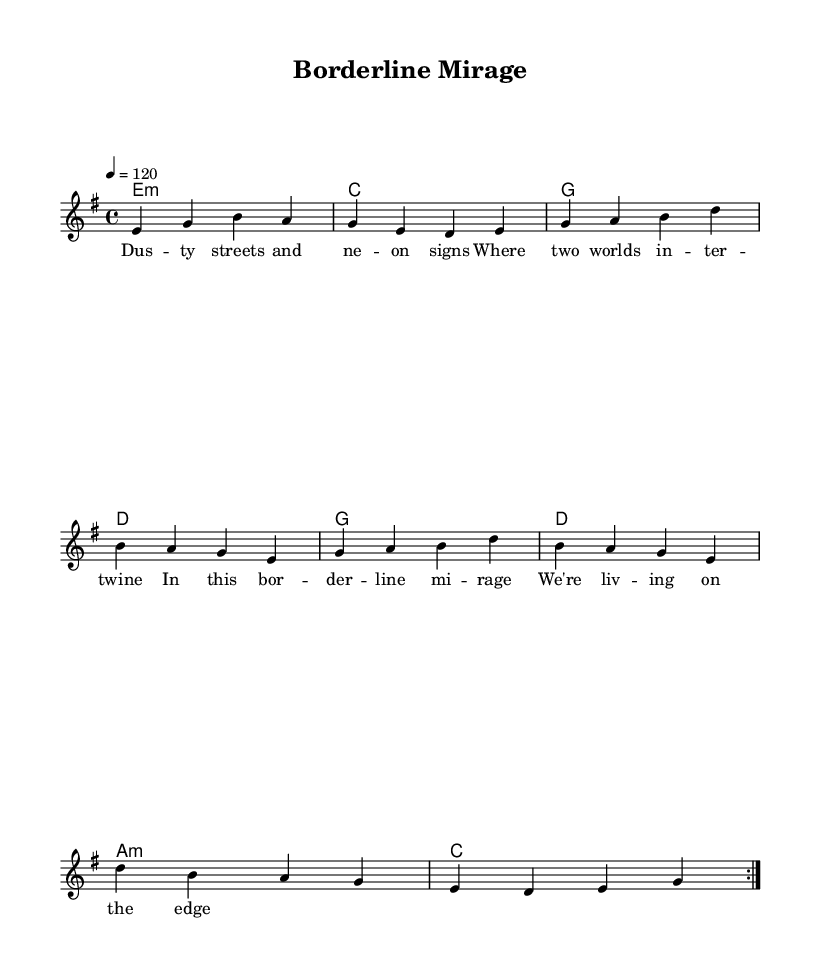What is the key signature of this music? The key signature is indicated at the beginning of the staff, showing that there is one sharp, which corresponds to E minor.
Answer: E minor What is the time signature of this music? The time signature is located next to the key signature at the beginning, which is four beats per measure, indicated as 4/4.
Answer: 4/4 What is the tempo marking of this piece? The tempo is indicated with a number and note value at the beginning of the score, showing 120 beats per minute, which is a moderate pace.
Answer: 120 How many measures are repeated in the melody? The score shows a 'repeat volta 2' directive, which indicates that the melody section is intended to be played two times.
Answer: 2 What chord is used on the first beat of the first measure? The first chord appears at the beginning of the harmonies section and is noted as an E minor chord, indicating its root and quality.
Answer: E minor What is the lyrical theme conveyed in the first verse? The lyrics mention "dusty streets" and "borderline mirage," suggesting a narrative intertwined with desert landscapes and experiences tied to a border town.
Answer: Borderline experience Which instrument is primarily featured in the lead part? Given the score layout, the lead voice is notated within the staff, indicating it will be played by a lead instrument, typically a guitar in rock music.
Answer: Guitar 